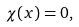<formula> <loc_0><loc_0><loc_500><loc_500>\chi ( x ) = 0 ,</formula> 